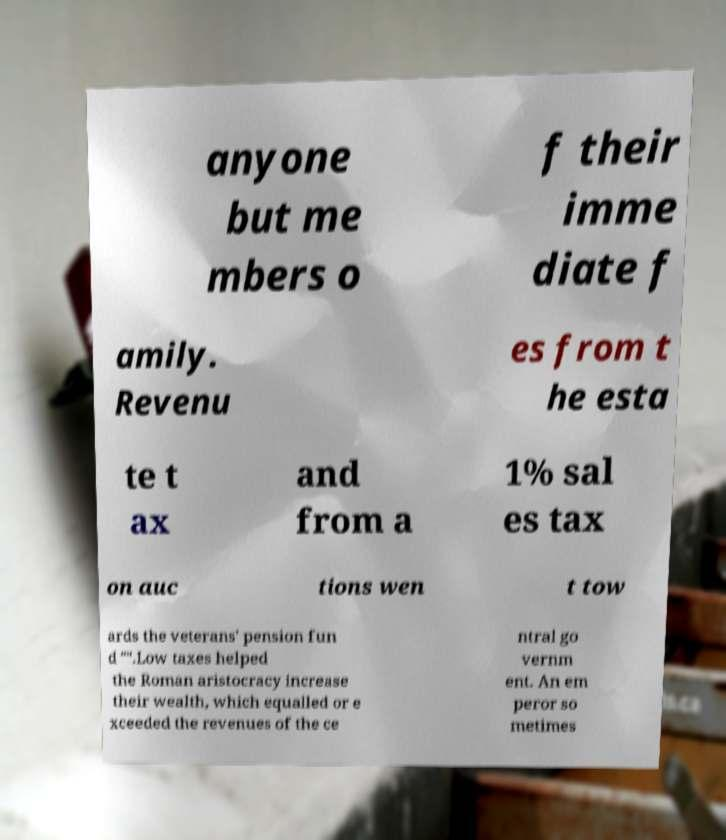What messages or text are displayed in this image? I need them in a readable, typed format. anyone but me mbers o f their imme diate f amily. Revenu es from t he esta te t ax and from a 1% sal es tax on auc tions wen t tow ards the veterans' pension fun d "".Low taxes helped the Roman aristocracy increase their wealth, which equalled or e xceeded the revenues of the ce ntral go vernm ent. An em peror so metimes 